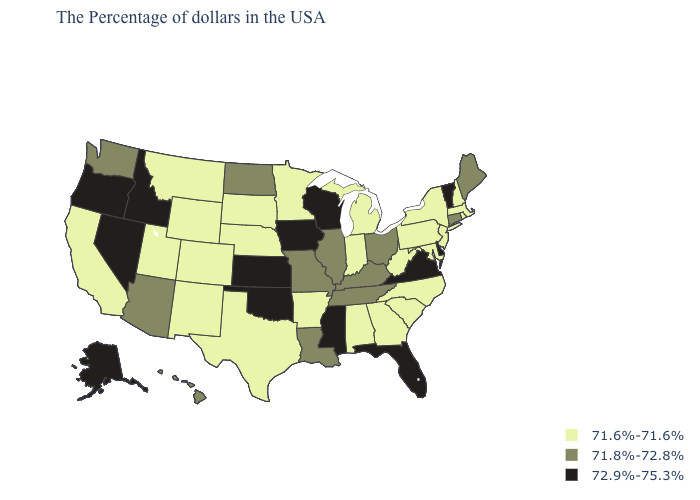Name the states that have a value in the range 71.8%-72.8%?
Quick response, please. Maine, Connecticut, Ohio, Kentucky, Tennessee, Illinois, Louisiana, Missouri, North Dakota, Arizona, Washington, Hawaii. Does New Jersey have the same value as Nevada?
Short answer required. No. What is the value of Louisiana?
Concise answer only. 71.8%-72.8%. Name the states that have a value in the range 71.6%-71.6%?
Be succinct. Massachusetts, Rhode Island, New Hampshire, New York, New Jersey, Maryland, Pennsylvania, North Carolina, South Carolina, West Virginia, Georgia, Michigan, Indiana, Alabama, Arkansas, Minnesota, Nebraska, Texas, South Dakota, Wyoming, Colorado, New Mexico, Utah, Montana, California. What is the highest value in the USA?
Write a very short answer. 72.9%-75.3%. Does Indiana have the highest value in the MidWest?
Concise answer only. No. What is the value of Arizona?
Give a very brief answer. 71.8%-72.8%. What is the value of Arizona?
Answer briefly. 71.8%-72.8%. What is the value of Florida?
Quick response, please. 72.9%-75.3%. What is the highest value in the MidWest ?
Quick response, please. 72.9%-75.3%. Does Michigan have the highest value in the USA?
Write a very short answer. No. Does Hawaii have the highest value in the USA?
Be succinct. No. Does the first symbol in the legend represent the smallest category?
Keep it brief. Yes. Among the states that border Nebraska , which have the lowest value?
Write a very short answer. South Dakota, Wyoming, Colorado. What is the value of Michigan?
Write a very short answer. 71.6%-71.6%. 